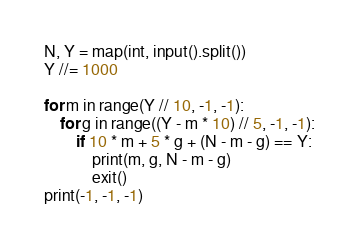<code> <loc_0><loc_0><loc_500><loc_500><_Python_>N, Y = map(int, input().split())
Y //= 1000

for m in range(Y // 10, -1, -1):
	for g in range((Y - m * 10) // 5, -1, -1):
		if 10 * m + 5 * g + (N - m - g) == Y:
			print(m, g, N - m - g)
			exit()
print(-1, -1, -1)</code> 